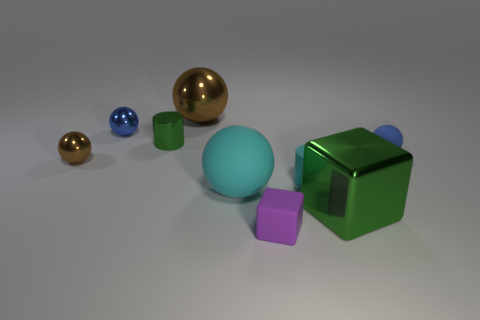How many other objects are there of the same shape as the large green metallic thing?
Your response must be concise. 1. How many big objects are in front of the small rubber cylinder?
Give a very brief answer. 2. What is the size of the thing that is both in front of the matte cylinder and on the right side of the purple block?
Ensure brevity in your answer.  Large. Are there any large brown objects?
Your answer should be compact. Yes. How many other things are there of the same size as the blue metal sphere?
Your answer should be very brief. 5. There is a small sphere that is in front of the tiny blue rubber thing; does it have the same color as the shiny thing in front of the tiny brown thing?
Provide a succinct answer. No. There is a cyan rubber thing that is the same shape as the small green metallic object; what size is it?
Your answer should be compact. Small. Is the material of the blue thing that is to the right of the big metallic cube the same as the tiny cylinder that is on the left side of the big cyan object?
Keep it short and to the point. No. What number of rubber objects are big brown objects or small blue cubes?
Ensure brevity in your answer.  0. The small blue thing that is on the left side of the small cylinder that is in front of the tiny blue thing right of the tiny matte cylinder is made of what material?
Give a very brief answer. Metal. 